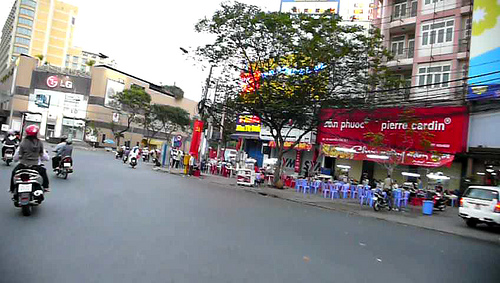What color is the chair? The chair seen in the image is blue. 